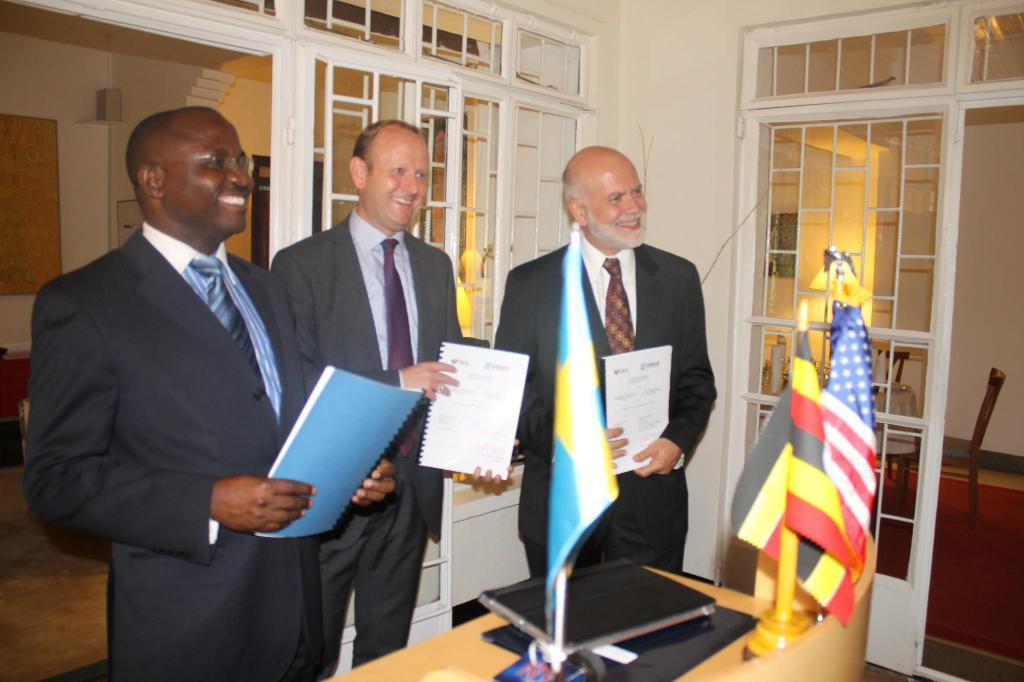How many people are in the image? There are three men in the image. What are the men doing in the image? The men are standing and holding books in their hands. What else can be seen in the image besides the men? There are flags on a table in the image. What type of cork can be seen on the wall in the image? There is no cork or wall present in the image. How do the men move around in the image? The men are standing still in the image and are not moving. 